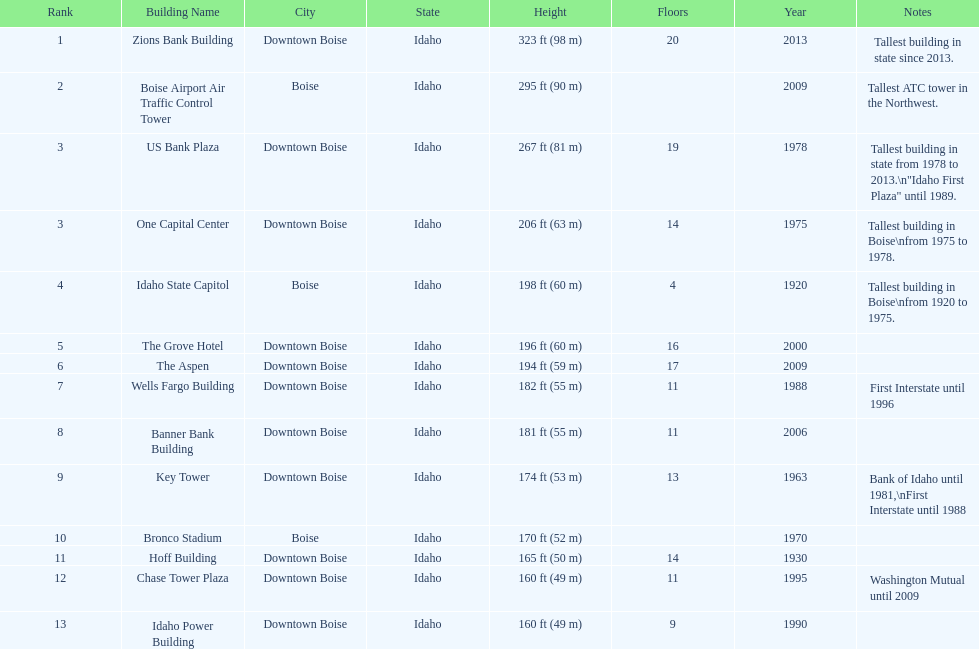How many of these buildings were built after 1975 8. 